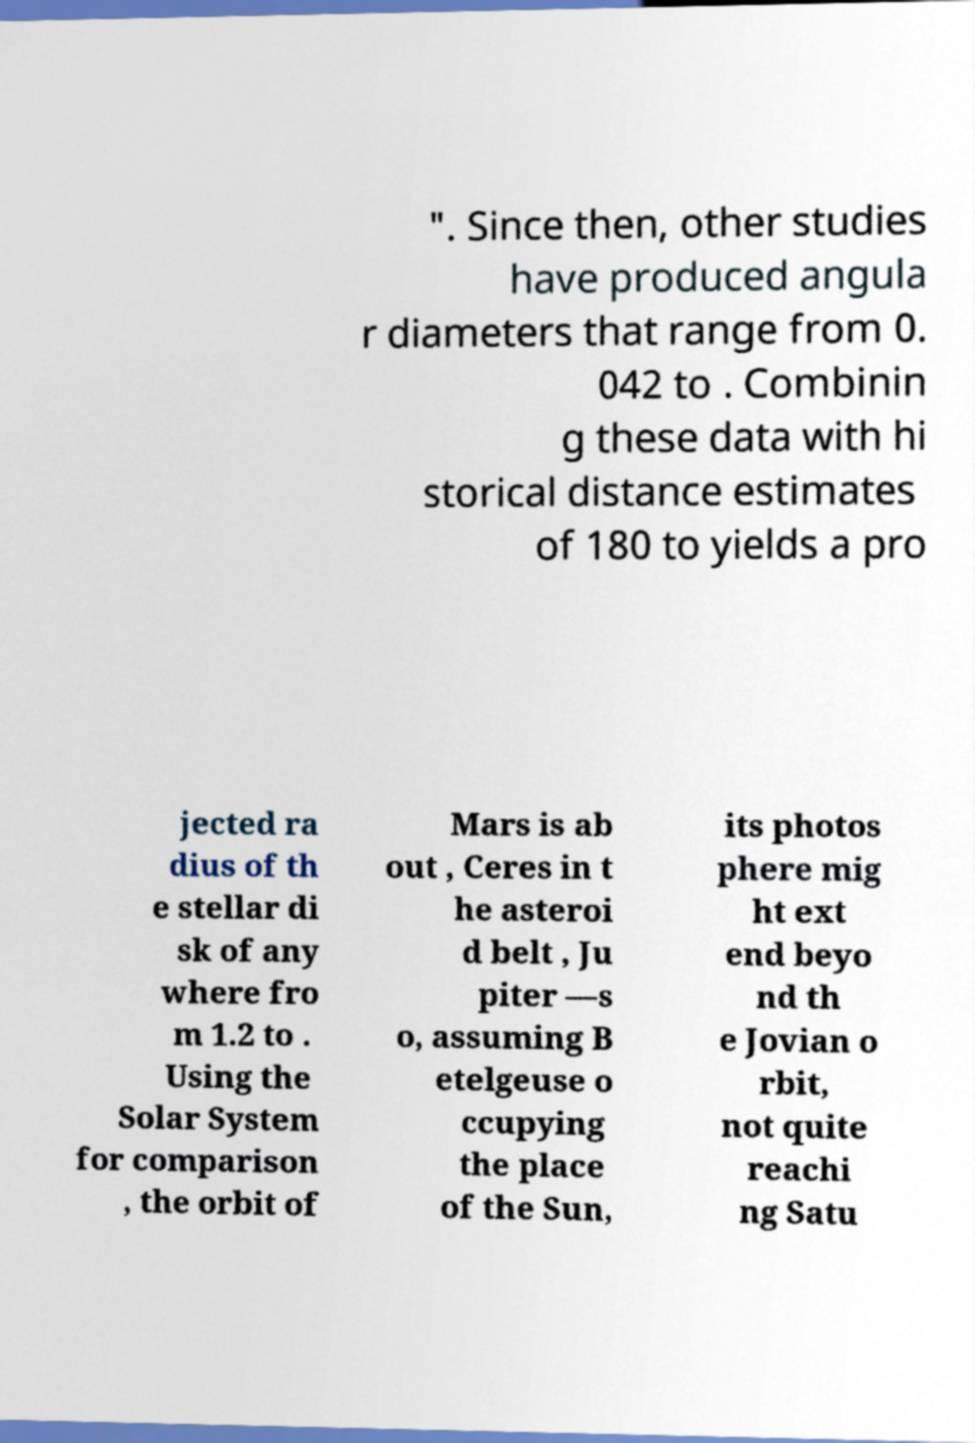Could you assist in decoding the text presented in this image and type it out clearly? ". Since then, other studies have produced angula r diameters that range from 0. 042 to . Combinin g these data with hi storical distance estimates of 180 to yields a pro jected ra dius of th e stellar di sk of any where fro m 1.2 to . Using the Solar System for comparison , the orbit of Mars is ab out , Ceres in t he asteroi d belt , Ju piter —s o, assuming B etelgeuse o ccupying the place of the Sun, its photos phere mig ht ext end beyo nd th e Jovian o rbit, not quite reachi ng Satu 